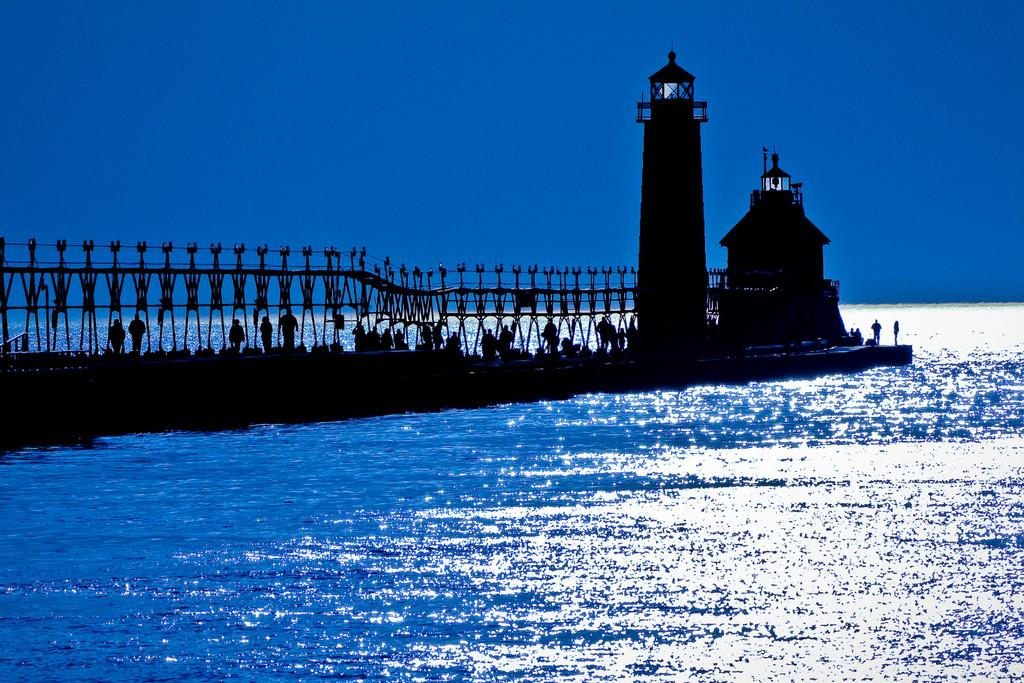What structure can be seen in the image that connects two land masses? There is a bridge in the image that connects two land masses. What are the people on the bridge doing? The people standing on the bridge are likely observing the view or crossing the bridge. What feature is present on the bridge for safety? There is a railing on the bridge for safety. What other notable structure can be seen in the image? There is a lighthouse in the image. What type of body of water is visible in the image? There is a sea visible in the image. How would you describe the weather based on the image? The sky is clear in the image, suggesting good weather. What day of the week is it in the image? The day of the week cannot be determined from the image. Is there any rain visible in the image? No, there is no rain visible in the image; the sky is clear. What type of road is present in the image? There is no road visible in the image; it features include a bridge, a lighthouse, and a sea. 